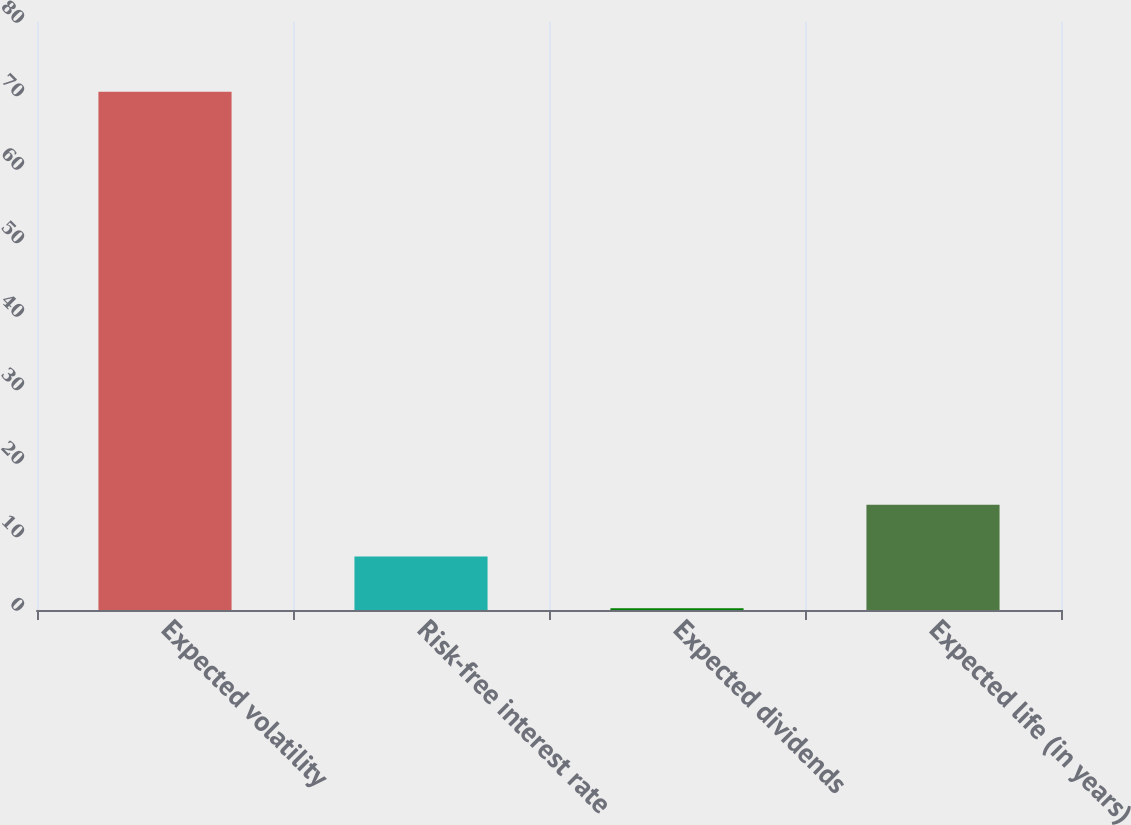<chart> <loc_0><loc_0><loc_500><loc_500><bar_chart><fcel>Expected volatility<fcel>Risk-free interest rate<fcel>Expected dividends<fcel>Expected life (in years)<nl><fcel>70.51<fcel>7.28<fcel>0.25<fcel>14.31<nl></chart> 